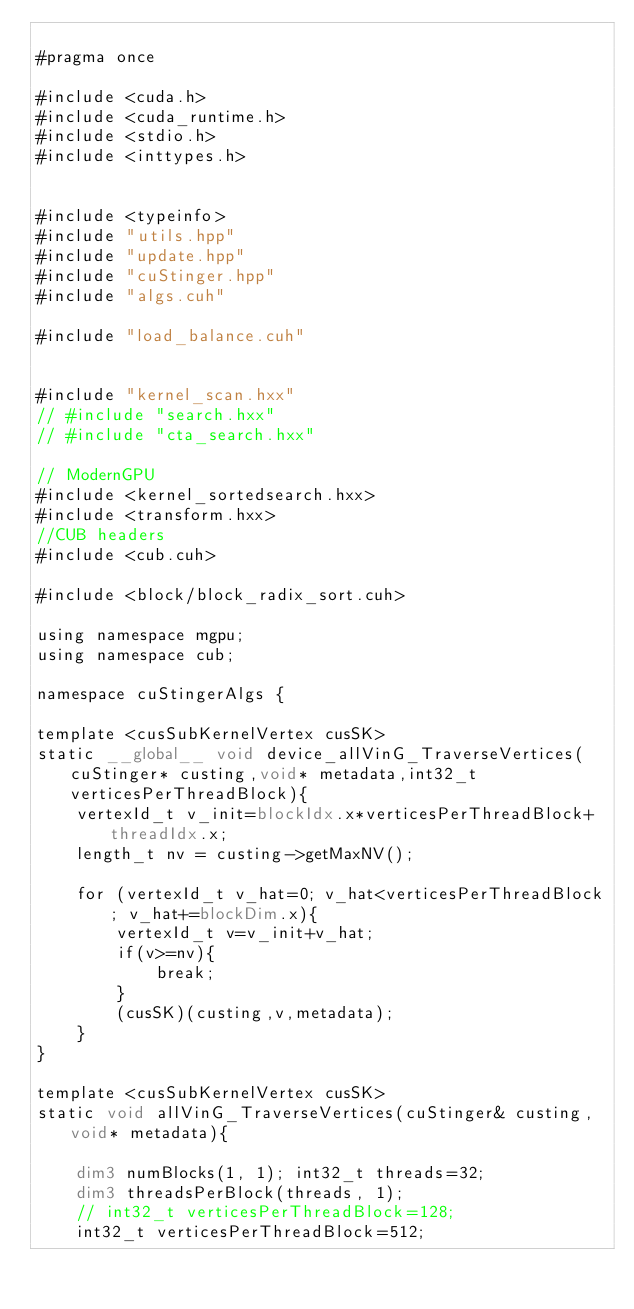<code> <loc_0><loc_0><loc_500><loc_500><_Cuda_>
#pragma once

#include <cuda.h>
#include <cuda_runtime.h>
#include <stdio.h>
#include <inttypes.h>


#include <typeinfo>
#include "utils.hpp"
#include "update.hpp"
#include "cuStinger.hpp"
#include "algs.cuh"

#include "load_balance.cuh"


#include "kernel_scan.hxx"
// #include "search.hxx"
// #include "cta_search.hxx"

// ModernGPU
#include <kernel_sortedsearch.hxx>
#include <transform.hxx>
//CUB headers
#include <cub.cuh>

#include <block/block_radix_sort.cuh>

using namespace mgpu;
using namespace cub;

namespace cuStingerAlgs {

template <cusSubKernelVertex cusSK>
static __global__ void device_allVinG_TraverseVertices(cuStinger* custing,void* metadata,int32_t verticesPerThreadBlock){
	vertexId_t v_init=blockIdx.x*verticesPerThreadBlock+threadIdx.x;
	length_t nv = custing->getMaxNV();

	for (vertexId_t v_hat=0; v_hat<verticesPerThreadBlock; v_hat+=blockDim.x){
		vertexId_t v=v_init+v_hat;
		if(v>=nv){
			break;
		}
		(cusSK)(custing,v,metadata);
	}
}

template <cusSubKernelVertex cusSK>
static void allVinG_TraverseVertices(cuStinger& custing,void* metadata){

	dim3 numBlocks(1, 1); int32_t threads=32;
	dim3 threadsPerBlock(threads, 1);
	// int32_t verticesPerThreadBlock=128;
	int32_t verticesPerThreadBlock=512;
</code> 